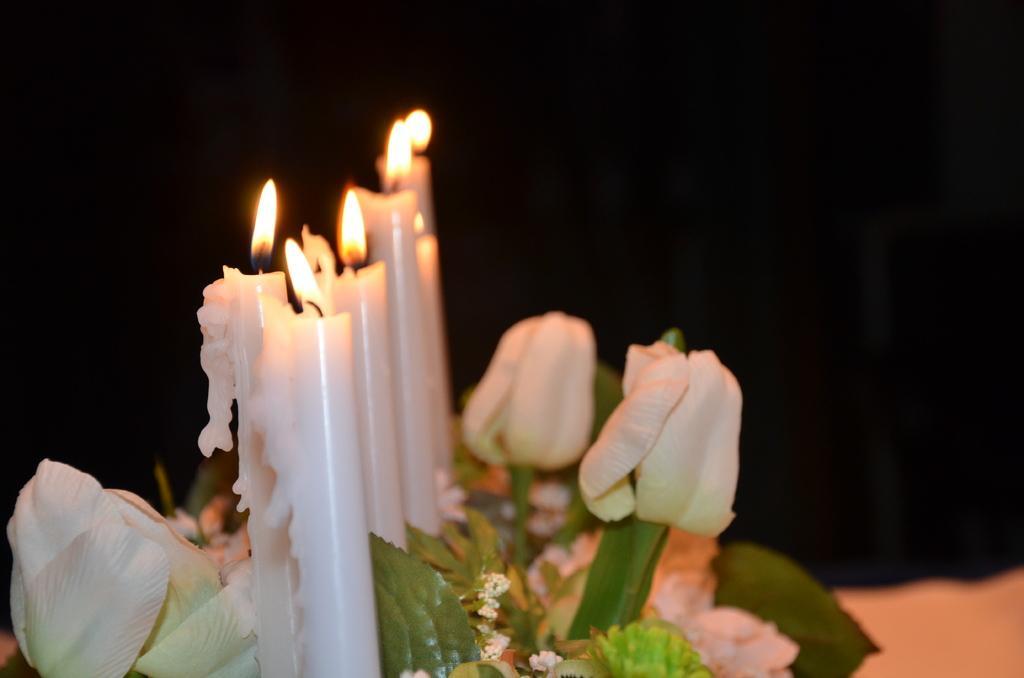Describe this image in one or two sentences. In this picture there are candles on the left side of the image and there are flowers at the bottom side of the image. 